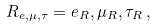<formula> <loc_0><loc_0><loc_500><loc_500>R _ { e , \mu , \tau } = e _ { R } , \mu _ { R } , \tau _ { R } \, ,</formula> 